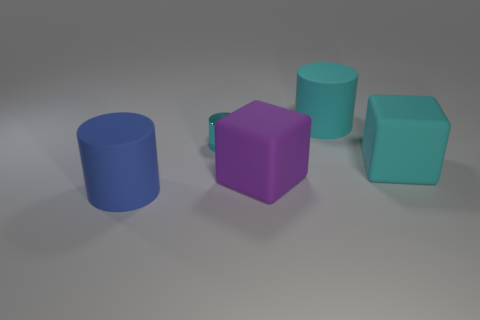The cube that is the same color as the small thing is what size?
Ensure brevity in your answer.  Large. How many blue cylinders are the same size as the purple rubber cube?
Offer a terse response. 1. The rubber thing that is in front of the tiny cyan object and on the right side of the purple matte block is what color?
Provide a succinct answer. Cyan. How many things are either big yellow balls or cyan matte cubes?
Make the answer very short. 1. How many large objects are either matte cylinders or yellow matte cylinders?
Provide a short and direct response. 2. Is there any other thing that has the same color as the tiny metal cylinder?
Your answer should be compact. Yes. There is a thing that is both in front of the metallic thing and behind the purple rubber object; what size is it?
Provide a short and direct response. Large. Does the cylinder to the left of the metallic cylinder have the same color as the large block that is right of the cyan rubber cylinder?
Provide a short and direct response. No. What number of other objects are there of the same material as the large cyan cylinder?
Offer a terse response. 3. What shape is the cyan object that is both to the left of the large cyan block and to the right of the cyan metallic object?
Offer a terse response. Cylinder. 